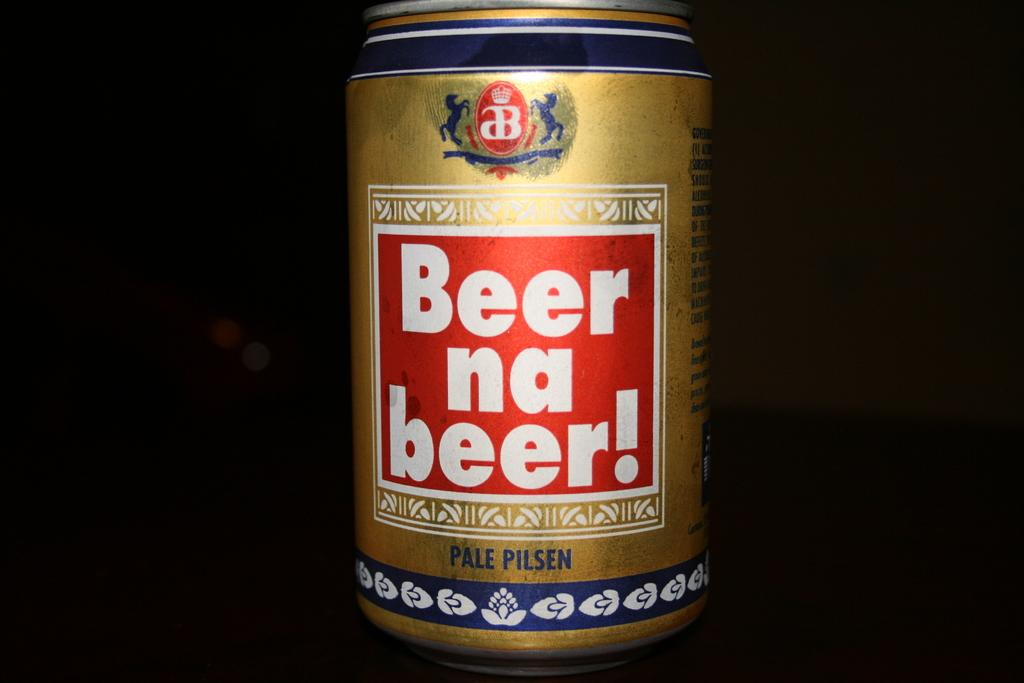<image>
Create a compact narrative representing the image presented. A brown can with a Beer na beer! label on front. 